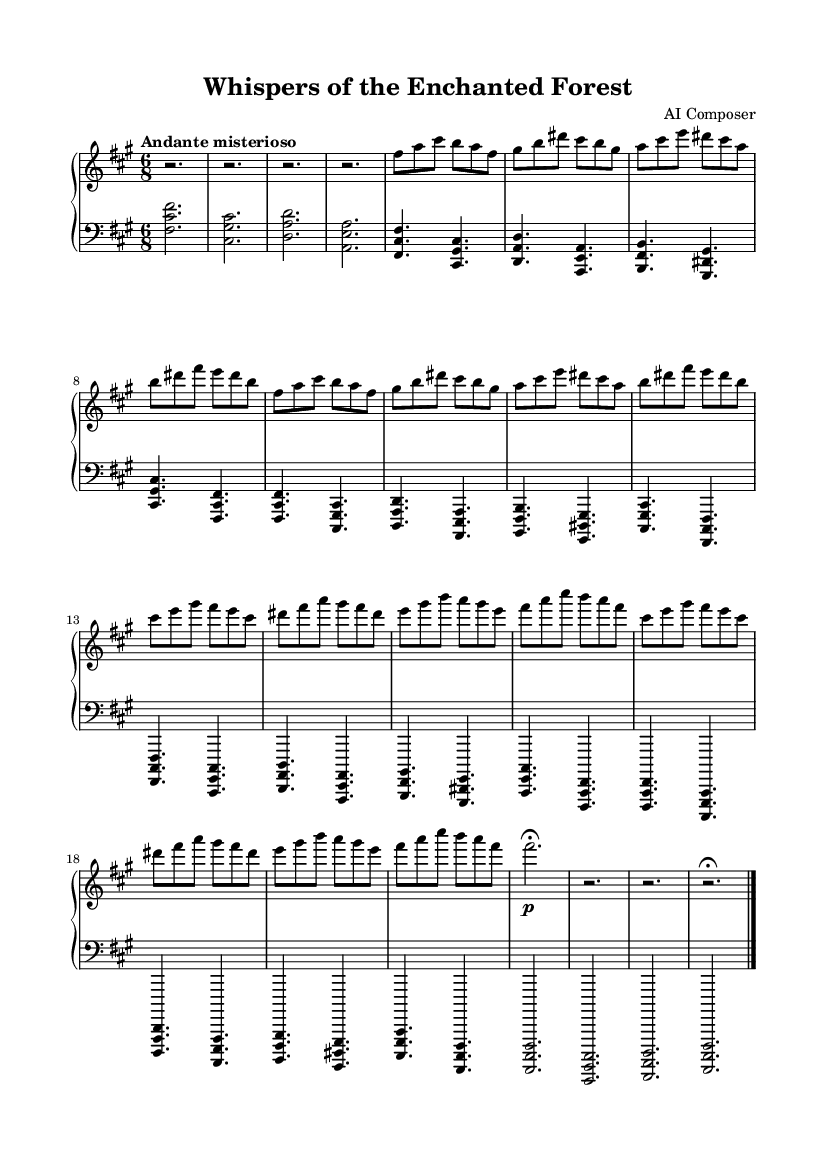What is the key signature of this piece? The key signature is indicated by the number of sharps or flats at the beginning of the staff. In this music, the presence of three sharps indicates that it is in F sharp minor.
Answer: F sharp minor What is the time signature of this music? The time signature is found at the beginning of the staff after the key signature. Here, the appearance of "6/8" indicates it is a compound time signature with six eighth notes per measure.
Answer: 6/8 What is the tempo marking for this piece? The tempo marking is usually noted above the staff, indicating the speed of the piece. In this case, "Andante misterioso" suggests a slow, slightly mysterious pace, typical for ethereal music.
Answer: Andante misterioso How many distinct themes does the piece contain? The music includes two sections labeled as Theme A and Theme B, both of which have their own melody and characteristics. By counting the labeled themes in the score, we identify that there are two distinct themes.
Answer: Two Which dynamic marking is present at the Coda? The Coda section has the dynamic marking of a fermata (indicated by the symbol above some notes) suggesting that the notes should be held for an extended duration. The exact placement of this marking in the Coda highlights its importance at the end of the piece.
Answer: Fermata What is the highest note in Theme A? By examining the notes played in Theme A, individually note the pitches used. The highest note in this section is "dis," which is the D sharp in the fifth octave. Identifying the pitches confirms this as the highest in that theme.
Answer: D sharp 